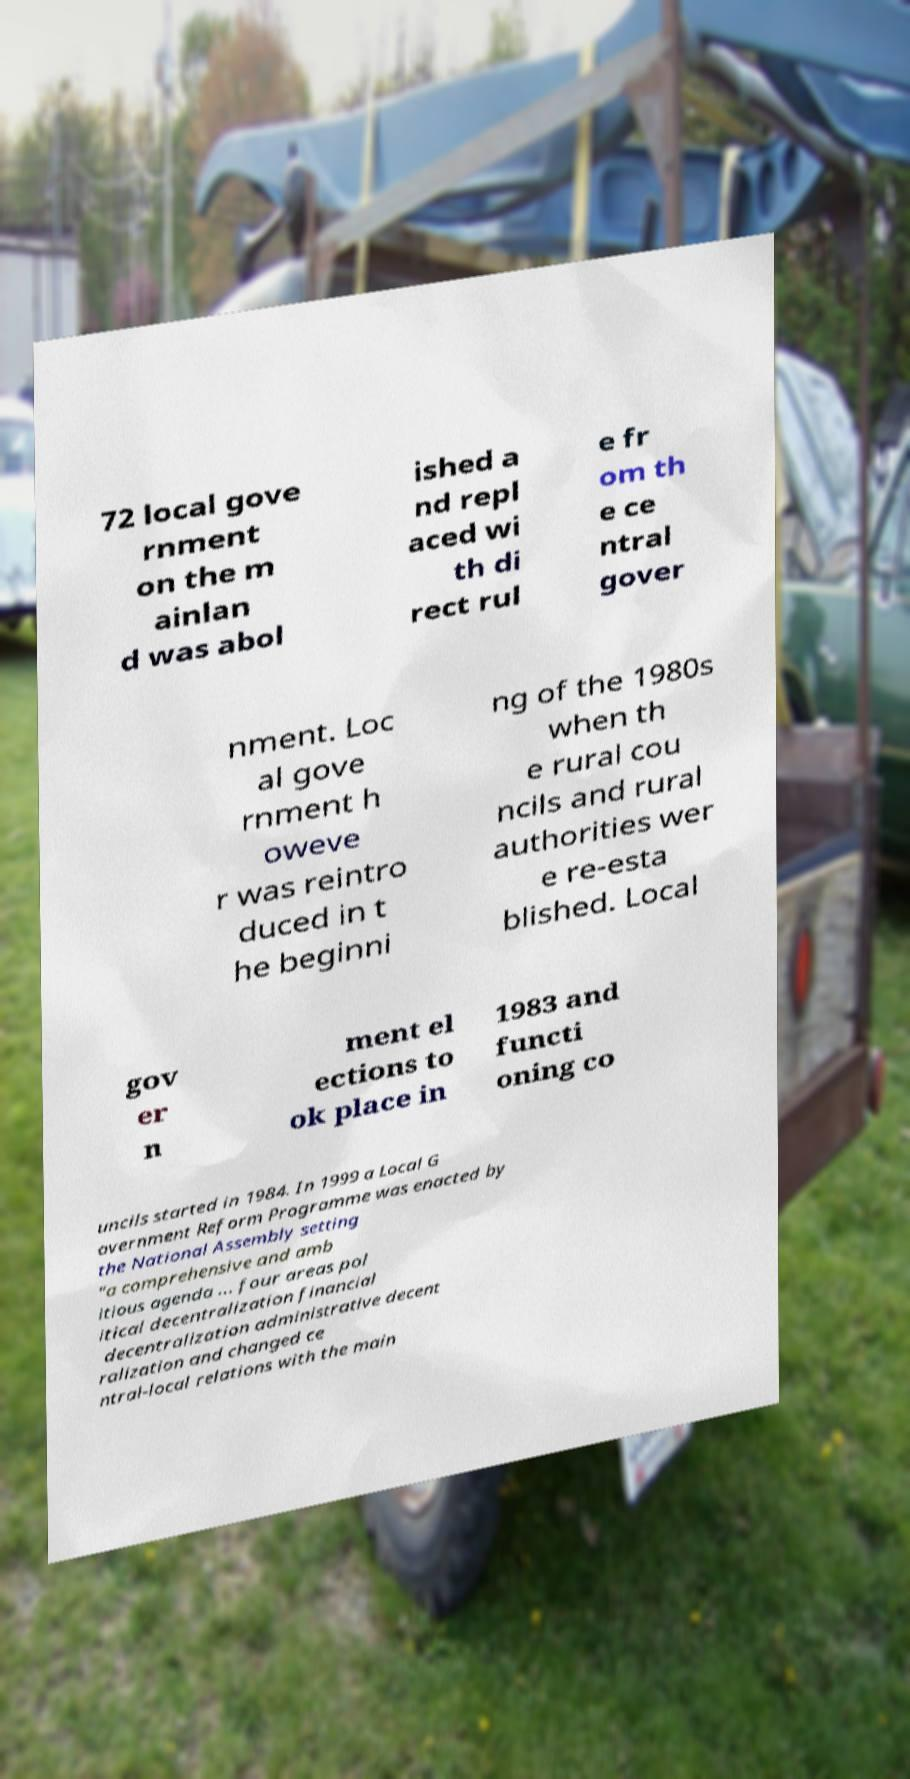Can you accurately transcribe the text from the provided image for me? 72 local gove rnment on the m ainlan d was abol ished a nd repl aced wi th di rect rul e fr om th e ce ntral gover nment. Loc al gove rnment h oweve r was reintro duced in t he beginni ng of the 1980s when th e rural cou ncils and rural authorities wer e re-esta blished. Local gov er n ment el ections to ok place in 1983 and functi oning co uncils started in 1984. In 1999 a Local G overnment Reform Programme was enacted by the National Assembly setting "a comprehensive and amb itious agenda ... four areas pol itical decentralization financial decentralization administrative decent ralization and changed ce ntral-local relations with the main 